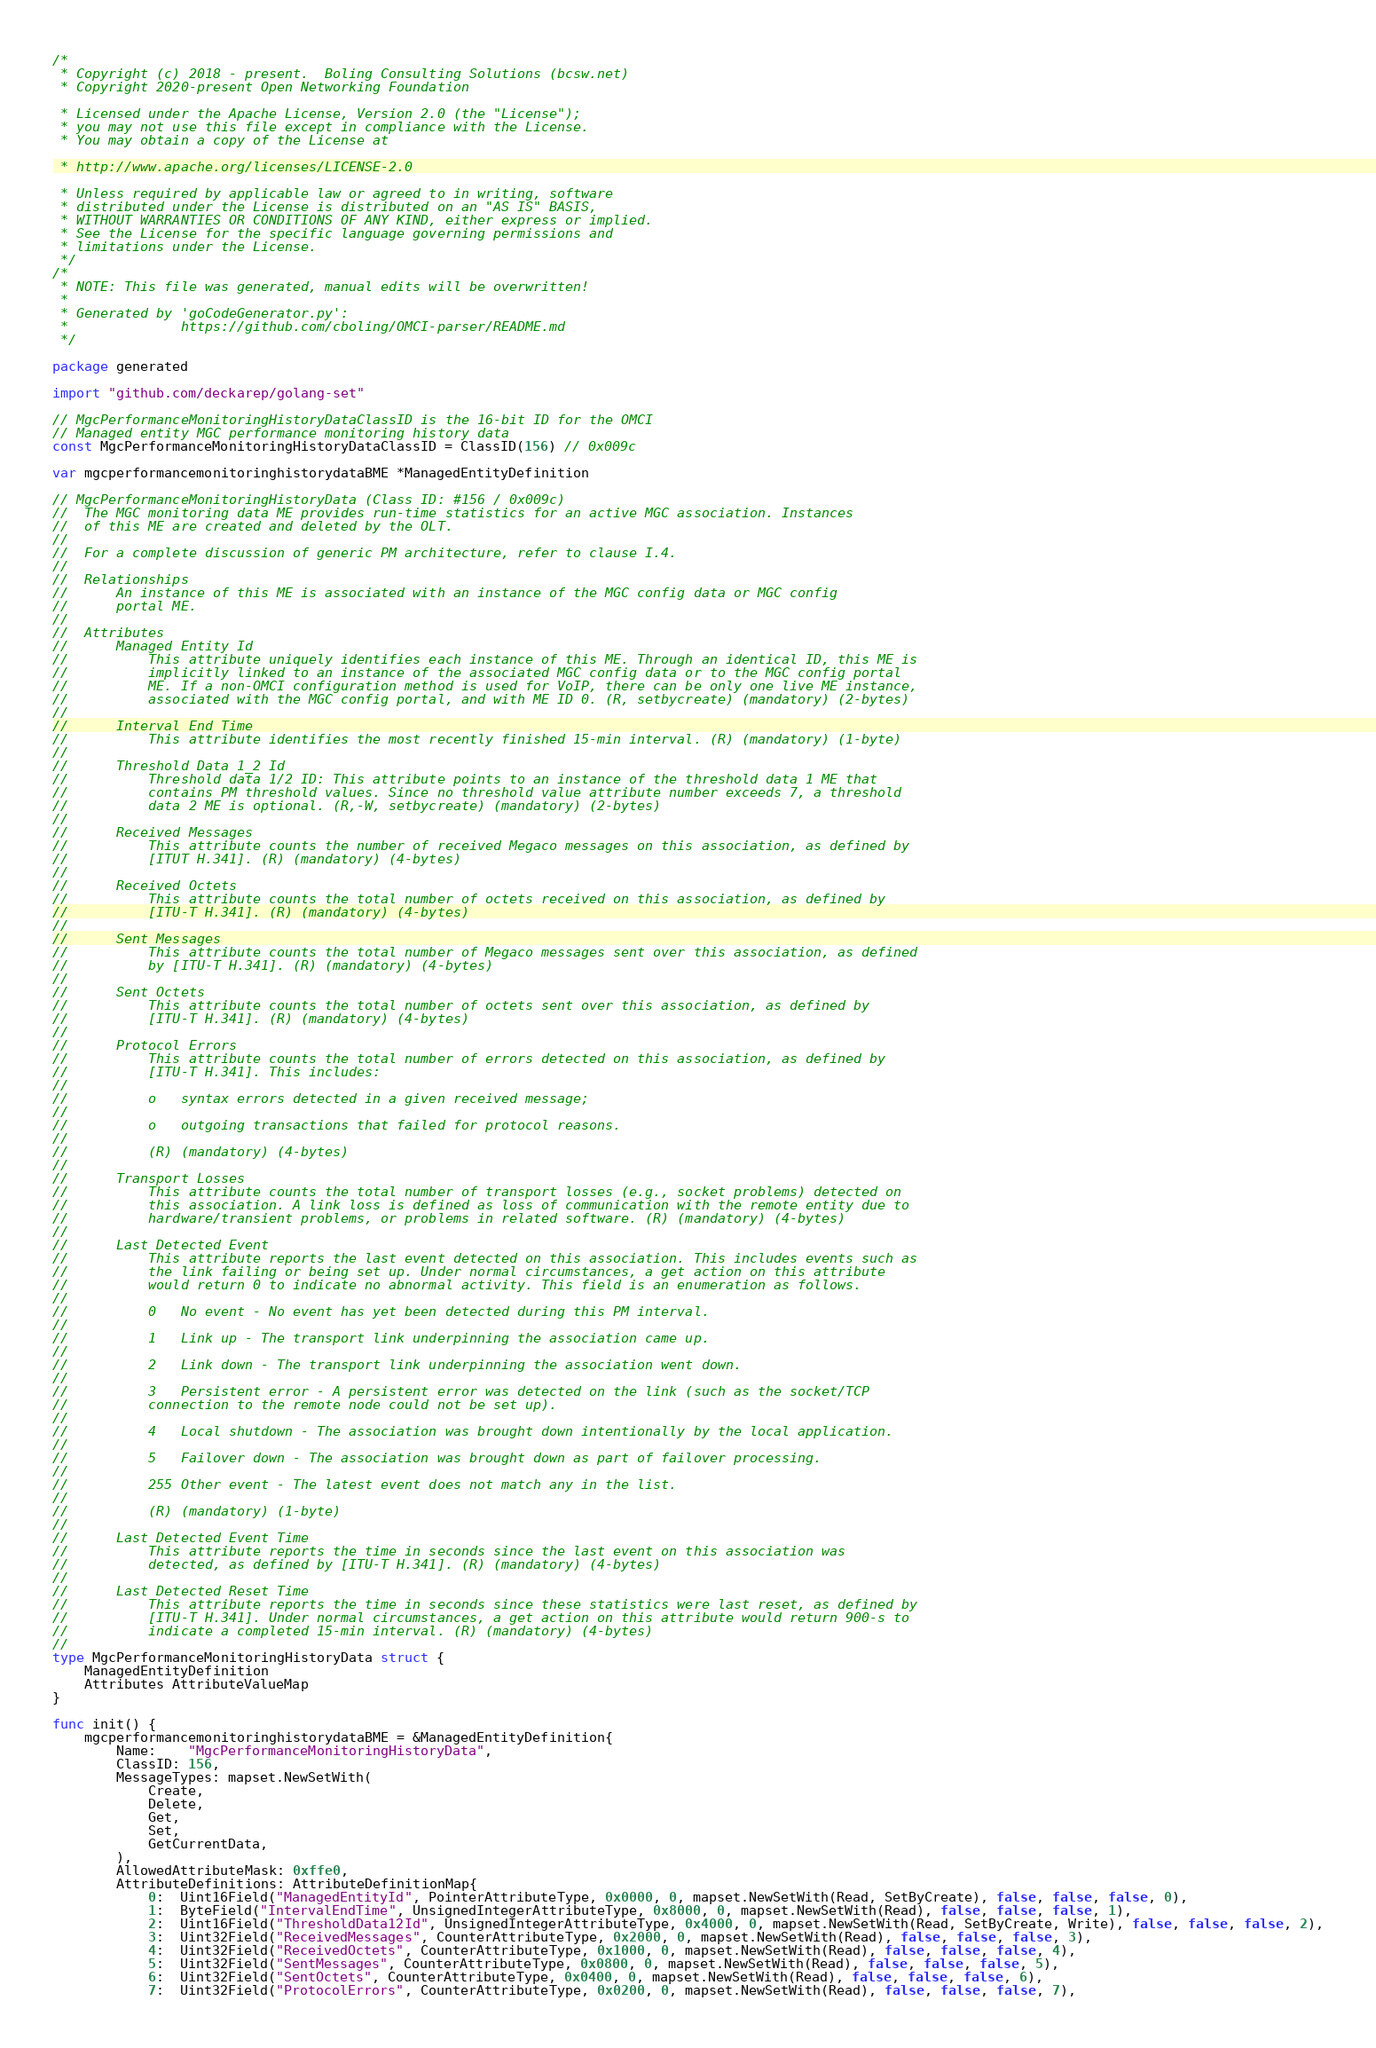<code> <loc_0><loc_0><loc_500><loc_500><_Go_>/*
 * Copyright (c) 2018 - present.  Boling Consulting Solutions (bcsw.net)
 * Copyright 2020-present Open Networking Foundation

 * Licensed under the Apache License, Version 2.0 (the "License");
 * you may not use this file except in compliance with the License.
 * You may obtain a copy of the License at

 * http://www.apache.org/licenses/LICENSE-2.0

 * Unless required by applicable law or agreed to in writing, software
 * distributed under the License is distributed on an "AS IS" BASIS,
 * WITHOUT WARRANTIES OR CONDITIONS OF ANY KIND, either express or implied.
 * See the License for the specific language governing permissions and
 * limitations under the License.
 */
/*
 * NOTE: This file was generated, manual edits will be overwritten!
 *
 * Generated by 'goCodeGenerator.py':
 *              https://github.com/cboling/OMCI-parser/README.md
 */

package generated

import "github.com/deckarep/golang-set"

// MgcPerformanceMonitoringHistoryDataClassID is the 16-bit ID for the OMCI
// Managed entity MGC performance monitoring history data
const MgcPerformanceMonitoringHistoryDataClassID = ClassID(156) // 0x009c

var mgcperformancemonitoringhistorydataBME *ManagedEntityDefinition

// MgcPerformanceMonitoringHistoryData (Class ID: #156 / 0x009c)
//	The MGC monitoring data ME provides run-time statistics for an active MGC association. Instances
//	of this ME are created and deleted by the OLT.
//
//	For a complete discussion of generic PM architecture, refer to clause I.4.
//
//	Relationships
//		An instance of this ME is associated with an instance of the MGC config data or MGC config
//		portal ME.
//
//	Attributes
//		Managed Entity Id
//			This attribute uniquely identifies each instance of this ME. Through an identical ID, this ME is
//			implicitly linked to an instance of the associated MGC config data or to the MGC config portal
//			ME. If a non-OMCI configuration method is used for VoIP, there can be only one live ME instance,
//			associated with the MGC config portal, and with ME ID 0. (R, setbycreate) (mandatory) (2-bytes)
//
//		Interval End Time
//			This attribute identifies the most recently finished 15-min interval. (R) (mandatory) (1-byte)
//
//		Threshold Data 1_2 Id
//			Threshold data 1/2 ID: This attribute points to an instance of the threshold data 1 ME that
//			contains PM threshold values. Since no threshold value attribute number exceeds 7, a threshold
//			data 2 ME is optional. (R,-W, setbycreate) (mandatory) (2-bytes)
//
//		Received Messages
//			This attribute counts the number of received Megaco messages on this association, as defined by
//			[ITUT H.341]. (R) (mandatory) (4-bytes)
//
//		Received Octets
//			This attribute counts the total number of octets received on this association, as defined by
//			[ITU-T H.341]. (R) (mandatory) (4-bytes)
//
//		Sent Messages
//			This attribute counts the total number of Megaco messages sent over this association, as defined
//			by [ITU-T H.341]. (R) (mandatory) (4-bytes)
//
//		Sent Octets
//			This attribute counts the total number of octets sent over this association, as defined by
//			[ITU-T H.341]. (R) (mandatory) (4-bytes)
//
//		Protocol Errors
//			This attribute counts the total number of errors detected on this association, as defined by
//			[ITU-T H.341]. This includes:
//
//			o	syntax errors detected in a given received message;
//
//			o	outgoing transactions that failed for protocol reasons.
//
//			(R) (mandatory) (4-bytes)
//
//		Transport Losses
//			This attribute counts the total number of transport losses (e.g., socket problems) detected on
//			this association. A link loss is defined as loss of communication with the remote entity due to
//			hardware/transient problems, or problems in related software. (R) (mandatory) (4-bytes)
//
//		Last Detected Event
//			This attribute reports the last event detected on this association. This includes events such as
//			the link failing or being set up. Under normal circumstances, a get action on this attribute
//			would return 0 to indicate no abnormal activity. This field is an enumeration as follows.
//
//			0	No event - No event has yet been detected during this PM interval.
//
//			1	Link up - The transport link underpinning the association came up.
//
//			2	Link down - The transport link underpinning the association went down.
//
//			3	Persistent error - A persistent error was detected on the link (such as the socket/TCP
//			connection to the remote node could not be set up).
//
//			4	Local shutdown - The association was brought down intentionally by the local application.
//
//			5	Failover down - The association was brought down as part of failover processing.
//
//			255	Other event - The latest event does not match any in the list.
//
//			(R) (mandatory) (1-byte)
//
//		Last Detected Event Time
//			This attribute reports the time in seconds since the last event on this association was
//			detected, as defined by [ITU-T H.341]. (R) (mandatory) (4-bytes)
//
//		Last Detected Reset Time
//			This attribute reports the time in seconds since these statistics were last reset, as defined by
//			[ITU-T H.341]. Under normal circumstances, a get action on this attribute would return 900-s to
//			indicate a completed 15-min interval. (R) (mandatory) (4-bytes)
//
type MgcPerformanceMonitoringHistoryData struct {
	ManagedEntityDefinition
	Attributes AttributeValueMap
}

func init() {
	mgcperformancemonitoringhistorydataBME = &ManagedEntityDefinition{
		Name:    "MgcPerformanceMonitoringHistoryData",
		ClassID: 156,
		MessageTypes: mapset.NewSetWith(
			Create,
			Delete,
			Get,
			Set,
			GetCurrentData,
		),
		AllowedAttributeMask: 0xffe0,
		AttributeDefinitions: AttributeDefinitionMap{
			0:  Uint16Field("ManagedEntityId", PointerAttributeType, 0x0000, 0, mapset.NewSetWith(Read, SetByCreate), false, false, false, 0),
			1:  ByteField("IntervalEndTime", UnsignedIntegerAttributeType, 0x8000, 0, mapset.NewSetWith(Read), false, false, false, 1),
			2:  Uint16Field("ThresholdData12Id", UnsignedIntegerAttributeType, 0x4000, 0, mapset.NewSetWith(Read, SetByCreate, Write), false, false, false, 2),
			3:  Uint32Field("ReceivedMessages", CounterAttributeType, 0x2000, 0, mapset.NewSetWith(Read), false, false, false, 3),
			4:  Uint32Field("ReceivedOctets", CounterAttributeType, 0x1000, 0, mapset.NewSetWith(Read), false, false, false, 4),
			5:  Uint32Field("SentMessages", CounterAttributeType, 0x0800, 0, mapset.NewSetWith(Read), false, false, false, 5),
			6:  Uint32Field("SentOctets", CounterAttributeType, 0x0400, 0, mapset.NewSetWith(Read), false, false, false, 6),
			7:  Uint32Field("ProtocolErrors", CounterAttributeType, 0x0200, 0, mapset.NewSetWith(Read), false, false, false, 7),</code> 